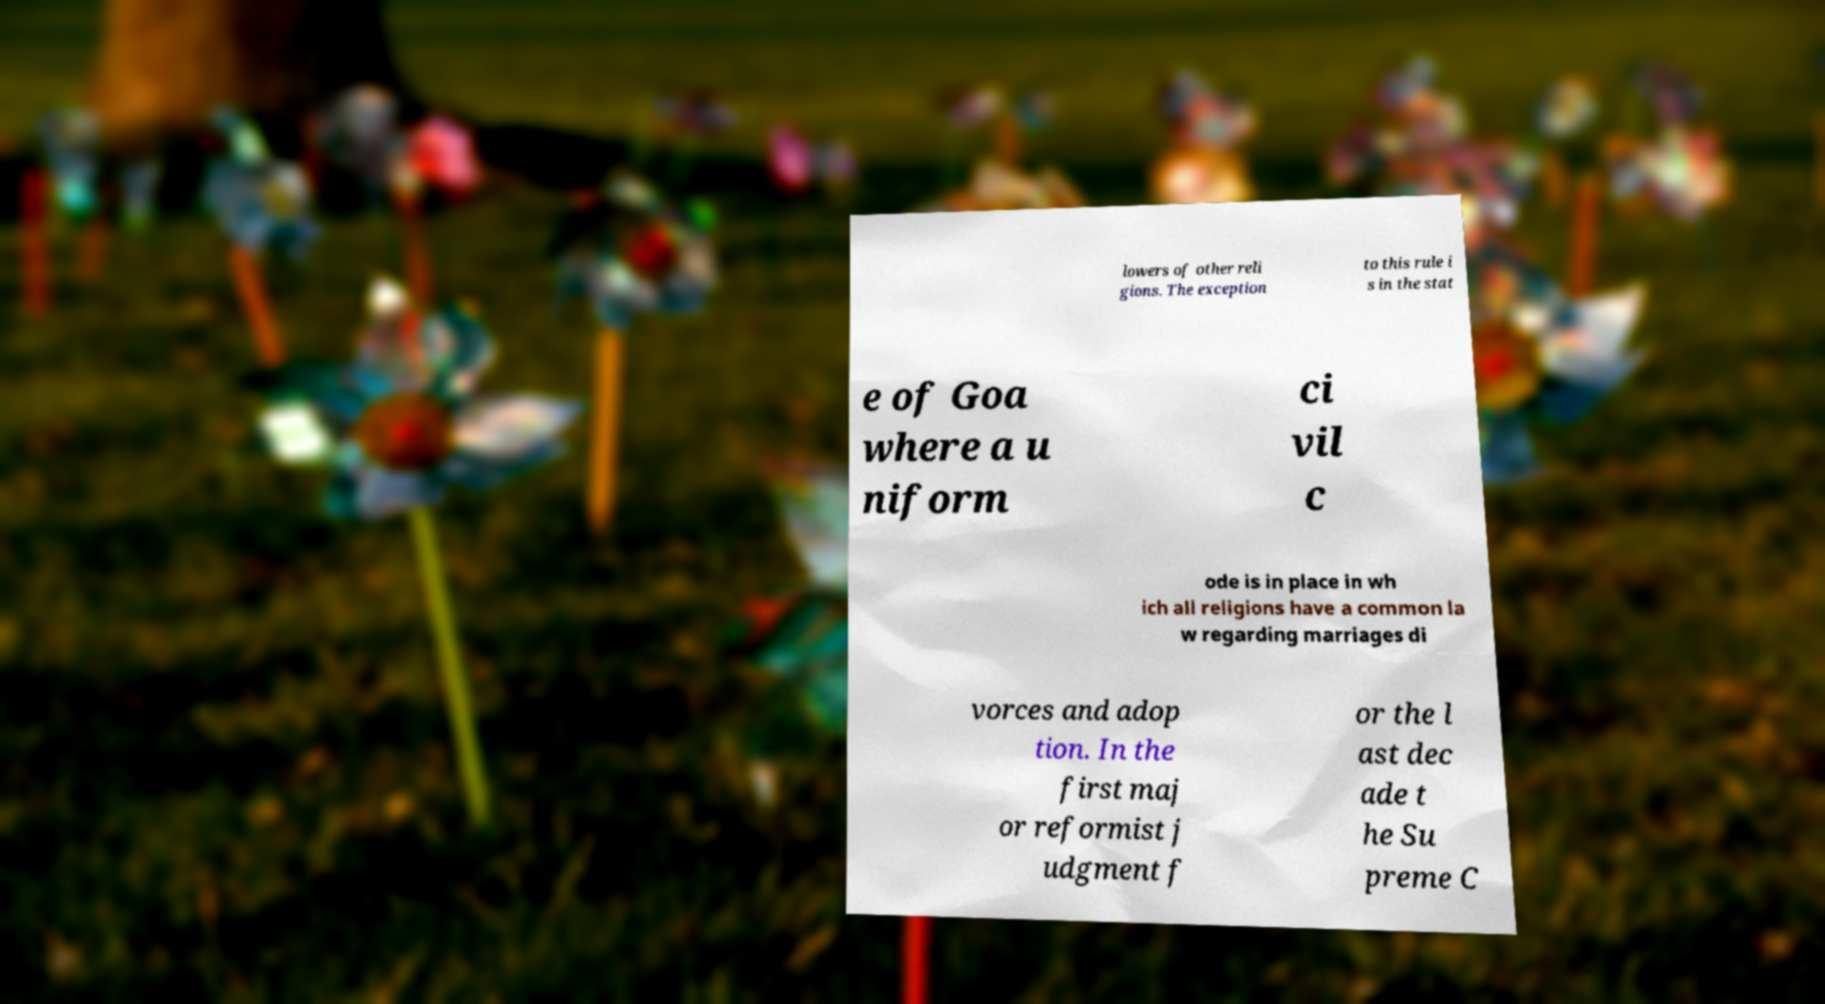There's text embedded in this image that I need extracted. Can you transcribe it verbatim? lowers of other reli gions. The exception to this rule i s in the stat e of Goa where a u niform ci vil c ode is in place in wh ich all religions have a common la w regarding marriages di vorces and adop tion. In the first maj or reformist j udgment f or the l ast dec ade t he Su preme C 